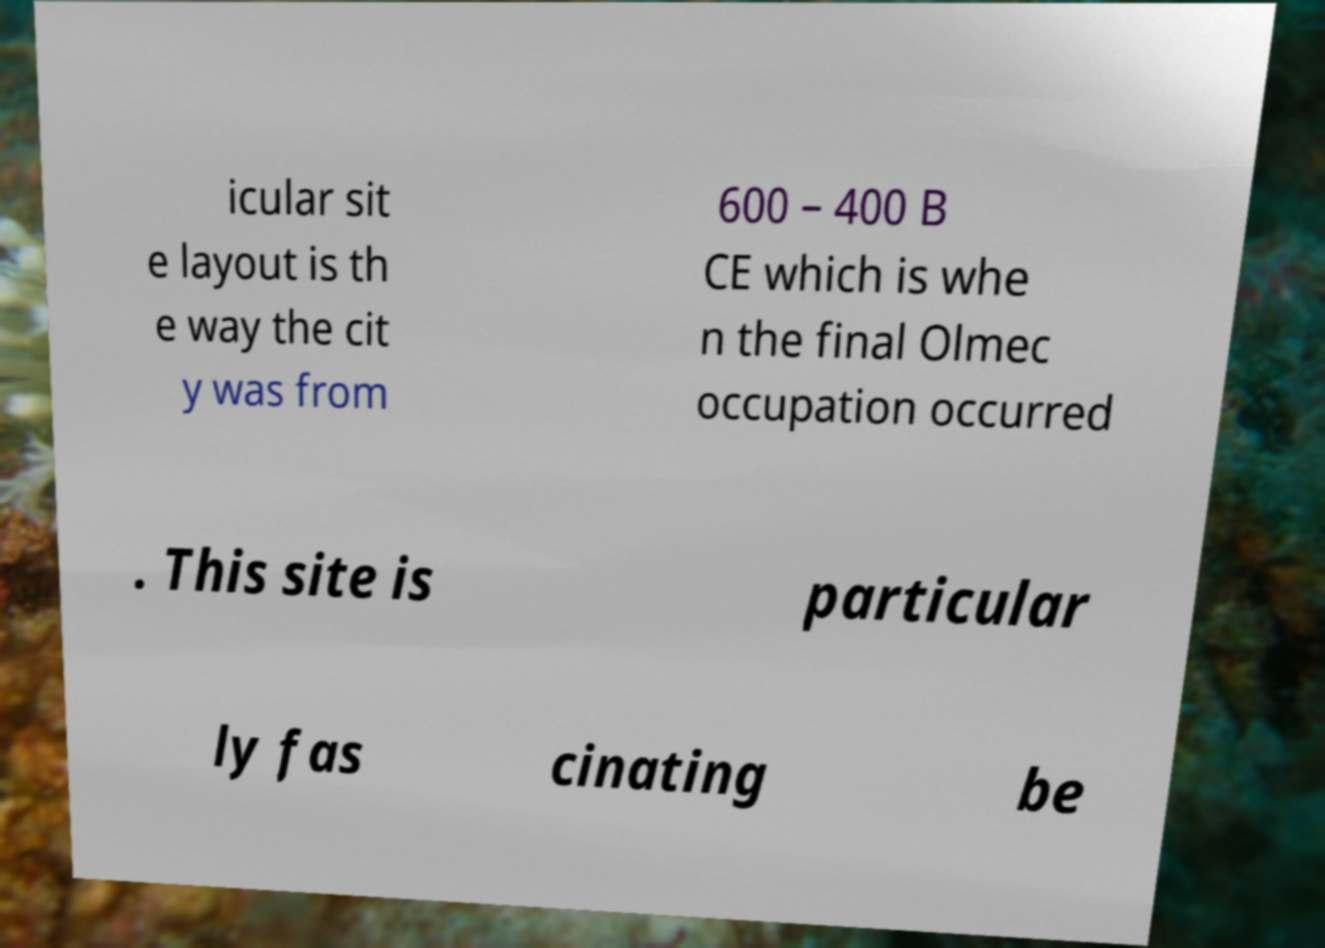There's text embedded in this image that I need extracted. Can you transcribe it verbatim? icular sit e layout is th e way the cit y was from 600 – 400 B CE which is whe n the final Olmec occupation occurred . This site is particular ly fas cinating be 